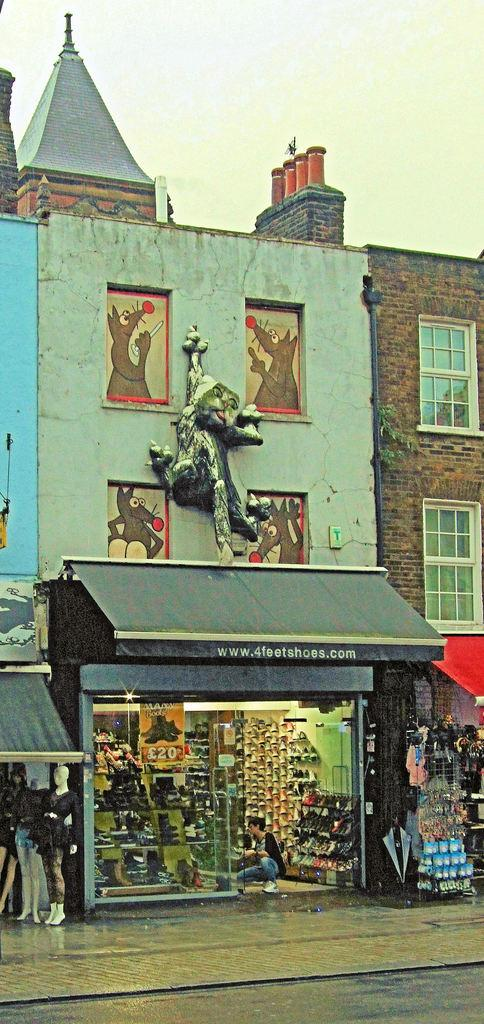What type of structure is present in the image? There is a building in the image. What can be found inside the building? It is a shop, and there are mannequins and footwear inside. What is the appearance of the building? The building has windows. Can you describe the presence of any other objects or features in the image? There is a sculpture, a road, and the sky is visible in the background. Are there any people in the image? Yes, there is a person in the shop. What type of food is being served on the sidewalk in the image? There is no mention of food or a sidewalk in the image. The image features a building, a sculpture, a shop with mannequins and footwear, a road, a person, and the sky in the background. 